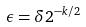<formula> <loc_0><loc_0><loc_500><loc_500>\epsilon = \delta 2 ^ { - k / 2 }</formula> 